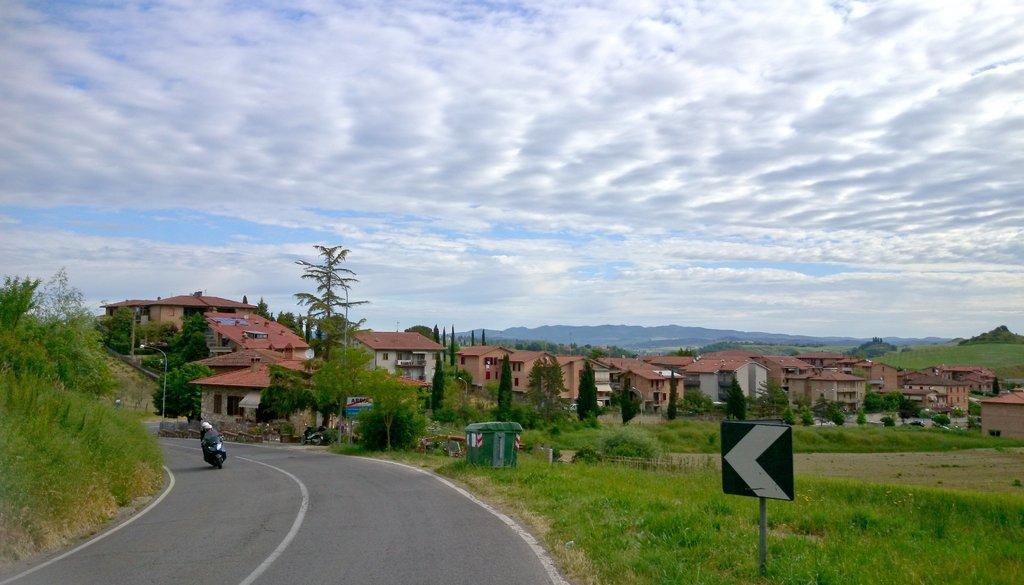How would you summarize this image in a sentence or two? In this picture we can see the road, signboard, plants, trees, buildings, motor bike with two people on it, mountains, banner, light pole and some objects and in the background we can see the sky with clouds. 